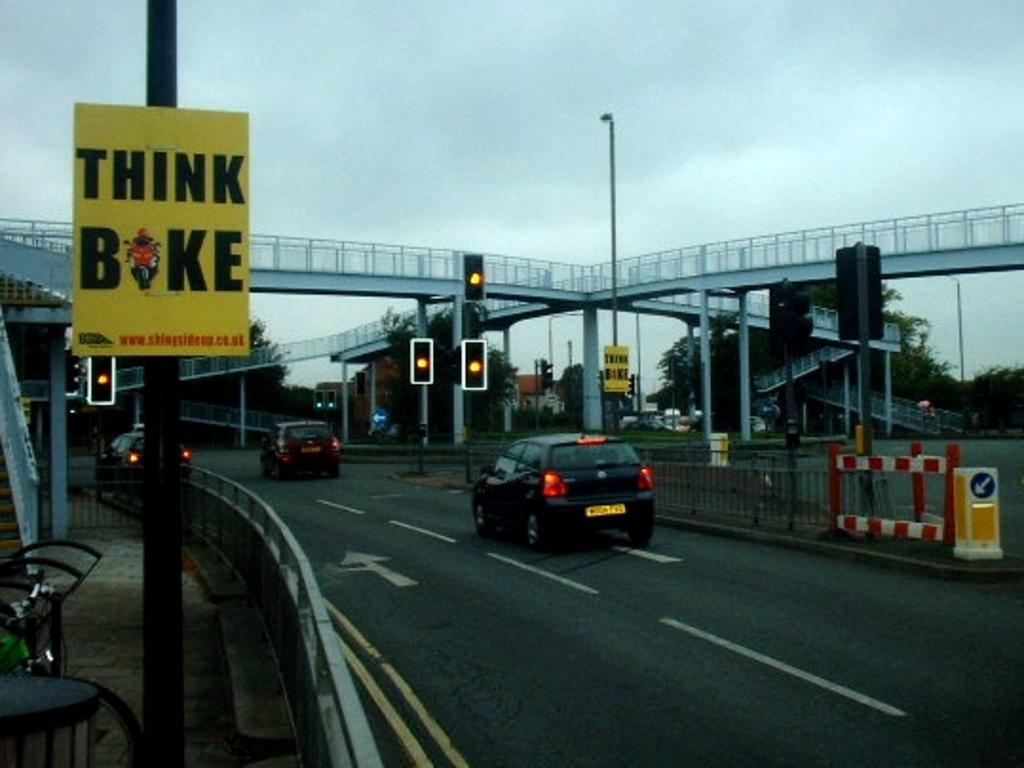Can you describe this image briefly? In this image there is a road and we can see cars on the road and there are poles, boards, traffic lights and trees. At the top there is a bridge and there is sky. 